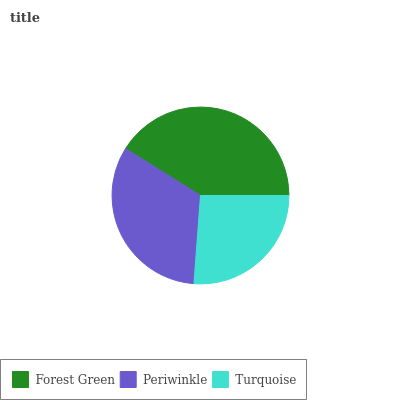Is Turquoise the minimum?
Answer yes or no. Yes. Is Forest Green the maximum?
Answer yes or no. Yes. Is Periwinkle the minimum?
Answer yes or no. No. Is Periwinkle the maximum?
Answer yes or no. No. Is Forest Green greater than Periwinkle?
Answer yes or no. Yes. Is Periwinkle less than Forest Green?
Answer yes or no. Yes. Is Periwinkle greater than Forest Green?
Answer yes or no. No. Is Forest Green less than Periwinkle?
Answer yes or no. No. Is Periwinkle the high median?
Answer yes or no. Yes. Is Periwinkle the low median?
Answer yes or no. Yes. Is Turquoise the high median?
Answer yes or no. No. Is Forest Green the low median?
Answer yes or no. No. 